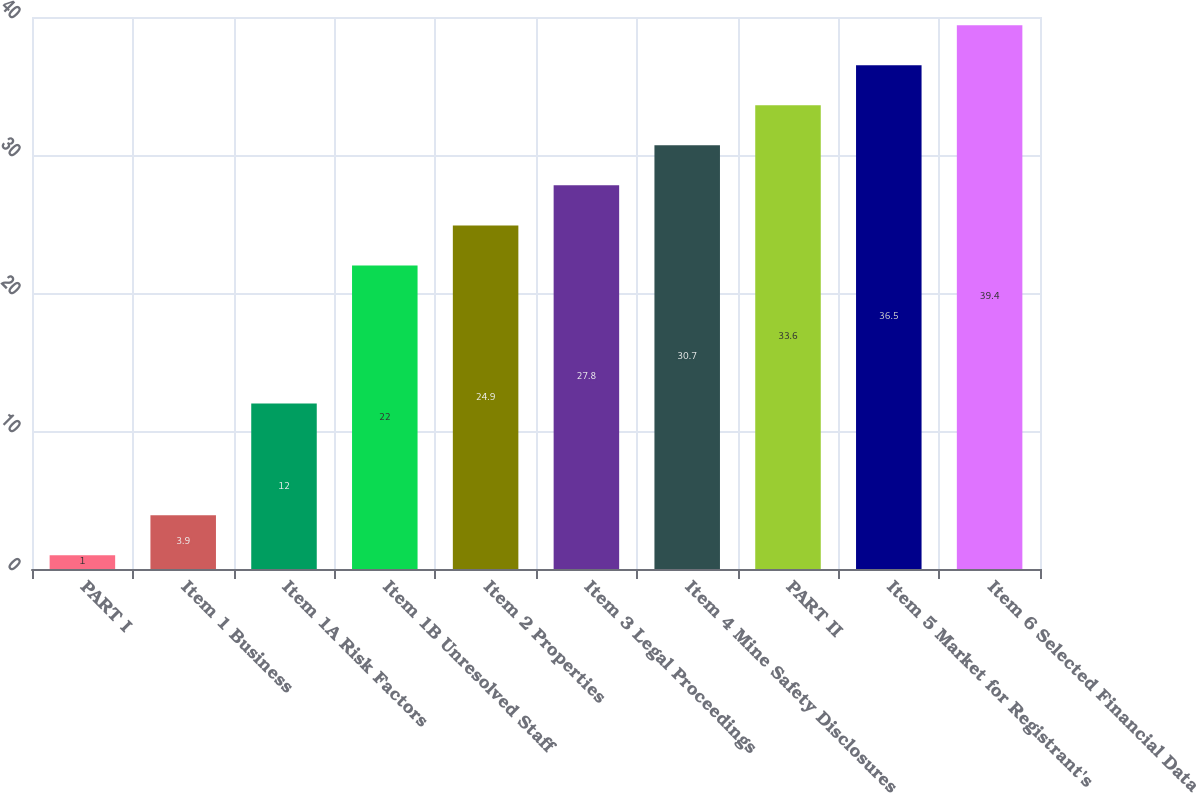Convert chart to OTSL. <chart><loc_0><loc_0><loc_500><loc_500><bar_chart><fcel>PART I<fcel>Item 1 Business<fcel>Item 1A Risk Factors<fcel>Item 1B Unresolved Staff<fcel>Item 2 Properties<fcel>Item 3 Legal Proceedings<fcel>Item 4 Mine Safety Disclosures<fcel>PART II<fcel>Item 5 Market for Registrant's<fcel>Item 6 Selected Financial Data<nl><fcel>1<fcel>3.9<fcel>12<fcel>22<fcel>24.9<fcel>27.8<fcel>30.7<fcel>33.6<fcel>36.5<fcel>39.4<nl></chart> 